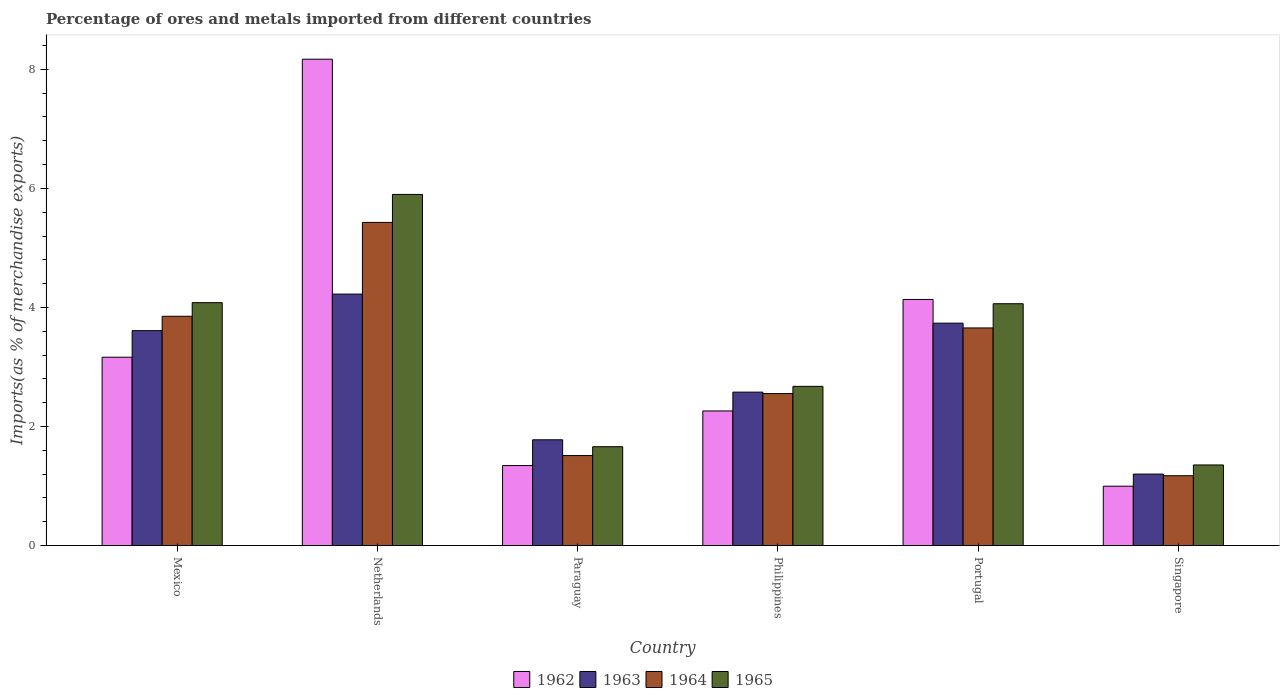How many different coloured bars are there?
Give a very brief answer. 4. How many bars are there on the 6th tick from the left?
Provide a short and direct response. 4. What is the label of the 6th group of bars from the left?
Provide a short and direct response. Singapore. In how many cases, is the number of bars for a given country not equal to the number of legend labels?
Make the answer very short. 0. What is the percentage of imports to different countries in 1964 in Paraguay?
Offer a very short reply. 1.51. Across all countries, what is the maximum percentage of imports to different countries in 1964?
Give a very brief answer. 5.43. Across all countries, what is the minimum percentage of imports to different countries in 1962?
Provide a short and direct response. 1. In which country was the percentage of imports to different countries in 1962 maximum?
Your response must be concise. Netherlands. In which country was the percentage of imports to different countries in 1962 minimum?
Offer a terse response. Singapore. What is the total percentage of imports to different countries in 1964 in the graph?
Give a very brief answer. 18.18. What is the difference between the percentage of imports to different countries in 1963 in Netherlands and that in Singapore?
Your answer should be compact. 3.02. What is the difference between the percentage of imports to different countries in 1962 in Singapore and the percentage of imports to different countries in 1964 in Philippines?
Your response must be concise. -1.56. What is the average percentage of imports to different countries in 1965 per country?
Make the answer very short. 3.29. What is the difference between the percentage of imports to different countries of/in 1963 and percentage of imports to different countries of/in 1962 in Paraguay?
Your answer should be compact. 0.43. In how many countries, is the percentage of imports to different countries in 1965 greater than 0.8 %?
Offer a terse response. 6. What is the ratio of the percentage of imports to different countries in 1963 in Philippines to that in Singapore?
Ensure brevity in your answer.  2.15. Is the percentage of imports to different countries in 1965 in Philippines less than that in Portugal?
Offer a very short reply. Yes. Is the difference between the percentage of imports to different countries in 1963 in Netherlands and Singapore greater than the difference between the percentage of imports to different countries in 1962 in Netherlands and Singapore?
Your answer should be very brief. No. What is the difference between the highest and the second highest percentage of imports to different countries in 1965?
Offer a terse response. -0.02. What is the difference between the highest and the lowest percentage of imports to different countries in 1963?
Make the answer very short. 3.02. In how many countries, is the percentage of imports to different countries in 1964 greater than the average percentage of imports to different countries in 1964 taken over all countries?
Provide a short and direct response. 3. Is it the case that in every country, the sum of the percentage of imports to different countries in 1963 and percentage of imports to different countries in 1965 is greater than the sum of percentage of imports to different countries in 1962 and percentage of imports to different countries in 1964?
Your answer should be very brief. No. What does the 3rd bar from the left in Portugal represents?
Your answer should be compact. 1964. Are all the bars in the graph horizontal?
Ensure brevity in your answer.  No. How many countries are there in the graph?
Offer a terse response. 6. What is the difference between two consecutive major ticks on the Y-axis?
Make the answer very short. 2. Are the values on the major ticks of Y-axis written in scientific E-notation?
Your answer should be very brief. No. Does the graph contain any zero values?
Offer a terse response. No. How many legend labels are there?
Keep it short and to the point. 4. What is the title of the graph?
Provide a short and direct response. Percentage of ores and metals imported from different countries. Does "1961" appear as one of the legend labels in the graph?
Keep it short and to the point. No. What is the label or title of the Y-axis?
Your answer should be compact. Imports(as % of merchandise exports). What is the Imports(as % of merchandise exports) in 1962 in Mexico?
Make the answer very short. 3.16. What is the Imports(as % of merchandise exports) in 1963 in Mexico?
Your answer should be compact. 3.61. What is the Imports(as % of merchandise exports) of 1964 in Mexico?
Your response must be concise. 3.85. What is the Imports(as % of merchandise exports) of 1965 in Mexico?
Offer a terse response. 4.08. What is the Imports(as % of merchandise exports) of 1962 in Netherlands?
Your answer should be very brief. 8.17. What is the Imports(as % of merchandise exports) in 1963 in Netherlands?
Provide a short and direct response. 4.22. What is the Imports(as % of merchandise exports) of 1964 in Netherlands?
Offer a very short reply. 5.43. What is the Imports(as % of merchandise exports) of 1965 in Netherlands?
Offer a terse response. 5.9. What is the Imports(as % of merchandise exports) in 1962 in Paraguay?
Your answer should be very brief. 1.34. What is the Imports(as % of merchandise exports) in 1963 in Paraguay?
Make the answer very short. 1.78. What is the Imports(as % of merchandise exports) in 1964 in Paraguay?
Your response must be concise. 1.51. What is the Imports(as % of merchandise exports) in 1965 in Paraguay?
Keep it short and to the point. 1.66. What is the Imports(as % of merchandise exports) of 1962 in Philippines?
Provide a short and direct response. 2.26. What is the Imports(as % of merchandise exports) in 1963 in Philippines?
Offer a very short reply. 2.58. What is the Imports(as % of merchandise exports) in 1964 in Philippines?
Provide a short and direct response. 2.55. What is the Imports(as % of merchandise exports) of 1965 in Philippines?
Keep it short and to the point. 2.67. What is the Imports(as % of merchandise exports) of 1962 in Portugal?
Give a very brief answer. 4.13. What is the Imports(as % of merchandise exports) in 1963 in Portugal?
Your response must be concise. 3.74. What is the Imports(as % of merchandise exports) in 1964 in Portugal?
Offer a very short reply. 3.66. What is the Imports(as % of merchandise exports) in 1965 in Portugal?
Your answer should be compact. 4.06. What is the Imports(as % of merchandise exports) in 1962 in Singapore?
Offer a terse response. 1. What is the Imports(as % of merchandise exports) in 1963 in Singapore?
Offer a terse response. 1.2. What is the Imports(as % of merchandise exports) in 1964 in Singapore?
Provide a short and direct response. 1.17. What is the Imports(as % of merchandise exports) of 1965 in Singapore?
Provide a succinct answer. 1.35. Across all countries, what is the maximum Imports(as % of merchandise exports) in 1962?
Provide a succinct answer. 8.17. Across all countries, what is the maximum Imports(as % of merchandise exports) of 1963?
Keep it short and to the point. 4.22. Across all countries, what is the maximum Imports(as % of merchandise exports) in 1964?
Give a very brief answer. 5.43. Across all countries, what is the maximum Imports(as % of merchandise exports) in 1965?
Your response must be concise. 5.9. Across all countries, what is the minimum Imports(as % of merchandise exports) of 1962?
Provide a succinct answer. 1. Across all countries, what is the minimum Imports(as % of merchandise exports) of 1963?
Give a very brief answer. 1.2. Across all countries, what is the minimum Imports(as % of merchandise exports) in 1964?
Keep it short and to the point. 1.17. Across all countries, what is the minimum Imports(as % of merchandise exports) of 1965?
Provide a succinct answer. 1.35. What is the total Imports(as % of merchandise exports) of 1962 in the graph?
Offer a very short reply. 20.07. What is the total Imports(as % of merchandise exports) in 1963 in the graph?
Ensure brevity in your answer.  17.13. What is the total Imports(as % of merchandise exports) of 1964 in the graph?
Provide a short and direct response. 18.18. What is the total Imports(as % of merchandise exports) of 1965 in the graph?
Offer a terse response. 19.73. What is the difference between the Imports(as % of merchandise exports) of 1962 in Mexico and that in Netherlands?
Give a very brief answer. -5.01. What is the difference between the Imports(as % of merchandise exports) in 1963 in Mexico and that in Netherlands?
Your answer should be very brief. -0.61. What is the difference between the Imports(as % of merchandise exports) in 1964 in Mexico and that in Netherlands?
Your response must be concise. -1.58. What is the difference between the Imports(as % of merchandise exports) in 1965 in Mexico and that in Netherlands?
Offer a terse response. -1.82. What is the difference between the Imports(as % of merchandise exports) of 1962 in Mexico and that in Paraguay?
Keep it short and to the point. 1.82. What is the difference between the Imports(as % of merchandise exports) of 1963 in Mexico and that in Paraguay?
Your answer should be very brief. 1.83. What is the difference between the Imports(as % of merchandise exports) in 1964 in Mexico and that in Paraguay?
Offer a very short reply. 2.34. What is the difference between the Imports(as % of merchandise exports) of 1965 in Mexico and that in Paraguay?
Your response must be concise. 2.42. What is the difference between the Imports(as % of merchandise exports) of 1962 in Mexico and that in Philippines?
Make the answer very short. 0.9. What is the difference between the Imports(as % of merchandise exports) of 1963 in Mexico and that in Philippines?
Provide a succinct answer. 1.03. What is the difference between the Imports(as % of merchandise exports) of 1964 in Mexico and that in Philippines?
Your answer should be very brief. 1.3. What is the difference between the Imports(as % of merchandise exports) in 1965 in Mexico and that in Philippines?
Offer a terse response. 1.41. What is the difference between the Imports(as % of merchandise exports) in 1962 in Mexico and that in Portugal?
Offer a very short reply. -0.97. What is the difference between the Imports(as % of merchandise exports) of 1963 in Mexico and that in Portugal?
Your response must be concise. -0.13. What is the difference between the Imports(as % of merchandise exports) of 1964 in Mexico and that in Portugal?
Offer a terse response. 0.2. What is the difference between the Imports(as % of merchandise exports) in 1965 in Mexico and that in Portugal?
Offer a very short reply. 0.02. What is the difference between the Imports(as % of merchandise exports) in 1962 in Mexico and that in Singapore?
Your answer should be very brief. 2.17. What is the difference between the Imports(as % of merchandise exports) of 1963 in Mexico and that in Singapore?
Your response must be concise. 2.41. What is the difference between the Imports(as % of merchandise exports) of 1964 in Mexico and that in Singapore?
Offer a terse response. 2.68. What is the difference between the Imports(as % of merchandise exports) in 1965 in Mexico and that in Singapore?
Offer a very short reply. 2.73. What is the difference between the Imports(as % of merchandise exports) in 1962 in Netherlands and that in Paraguay?
Your answer should be compact. 6.83. What is the difference between the Imports(as % of merchandise exports) of 1963 in Netherlands and that in Paraguay?
Provide a succinct answer. 2.45. What is the difference between the Imports(as % of merchandise exports) in 1964 in Netherlands and that in Paraguay?
Provide a succinct answer. 3.92. What is the difference between the Imports(as % of merchandise exports) of 1965 in Netherlands and that in Paraguay?
Provide a short and direct response. 4.24. What is the difference between the Imports(as % of merchandise exports) of 1962 in Netherlands and that in Philippines?
Your answer should be very brief. 5.91. What is the difference between the Imports(as % of merchandise exports) of 1963 in Netherlands and that in Philippines?
Offer a terse response. 1.65. What is the difference between the Imports(as % of merchandise exports) in 1964 in Netherlands and that in Philippines?
Give a very brief answer. 2.88. What is the difference between the Imports(as % of merchandise exports) in 1965 in Netherlands and that in Philippines?
Provide a short and direct response. 3.22. What is the difference between the Imports(as % of merchandise exports) of 1962 in Netherlands and that in Portugal?
Make the answer very short. 4.04. What is the difference between the Imports(as % of merchandise exports) of 1963 in Netherlands and that in Portugal?
Offer a terse response. 0.49. What is the difference between the Imports(as % of merchandise exports) of 1964 in Netherlands and that in Portugal?
Keep it short and to the point. 1.77. What is the difference between the Imports(as % of merchandise exports) in 1965 in Netherlands and that in Portugal?
Your answer should be very brief. 1.84. What is the difference between the Imports(as % of merchandise exports) of 1962 in Netherlands and that in Singapore?
Keep it short and to the point. 7.17. What is the difference between the Imports(as % of merchandise exports) of 1963 in Netherlands and that in Singapore?
Your answer should be very brief. 3.02. What is the difference between the Imports(as % of merchandise exports) in 1964 in Netherlands and that in Singapore?
Offer a terse response. 4.26. What is the difference between the Imports(as % of merchandise exports) of 1965 in Netherlands and that in Singapore?
Your response must be concise. 4.55. What is the difference between the Imports(as % of merchandise exports) of 1962 in Paraguay and that in Philippines?
Offer a terse response. -0.92. What is the difference between the Imports(as % of merchandise exports) of 1963 in Paraguay and that in Philippines?
Offer a terse response. -0.8. What is the difference between the Imports(as % of merchandise exports) in 1964 in Paraguay and that in Philippines?
Offer a terse response. -1.04. What is the difference between the Imports(as % of merchandise exports) in 1965 in Paraguay and that in Philippines?
Ensure brevity in your answer.  -1.01. What is the difference between the Imports(as % of merchandise exports) of 1962 in Paraguay and that in Portugal?
Give a very brief answer. -2.79. What is the difference between the Imports(as % of merchandise exports) of 1963 in Paraguay and that in Portugal?
Provide a short and direct response. -1.96. What is the difference between the Imports(as % of merchandise exports) of 1964 in Paraguay and that in Portugal?
Make the answer very short. -2.14. What is the difference between the Imports(as % of merchandise exports) of 1965 in Paraguay and that in Portugal?
Ensure brevity in your answer.  -2.4. What is the difference between the Imports(as % of merchandise exports) in 1962 in Paraguay and that in Singapore?
Provide a succinct answer. 0.35. What is the difference between the Imports(as % of merchandise exports) of 1963 in Paraguay and that in Singapore?
Your answer should be compact. 0.58. What is the difference between the Imports(as % of merchandise exports) in 1964 in Paraguay and that in Singapore?
Ensure brevity in your answer.  0.34. What is the difference between the Imports(as % of merchandise exports) of 1965 in Paraguay and that in Singapore?
Your response must be concise. 0.31. What is the difference between the Imports(as % of merchandise exports) in 1962 in Philippines and that in Portugal?
Your answer should be very brief. -1.87. What is the difference between the Imports(as % of merchandise exports) of 1963 in Philippines and that in Portugal?
Give a very brief answer. -1.16. What is the difference between the Imports(as % of merchandise exports) of 1964 in Philippines and that in Portugal?
Your answer should be very brief. -1.1. What is the difference between the Imports(as % of merchandise exports) of 1965 in Philippines and that in Portugal?
Keep it short and to the point. -1.39. What is the difference between the Imports(as % of merchandise exports) in 1962 in Philippines and that in Singapore?
Make the answer very short. 1.26. What is the difference between the Imports(as % of merchandise exports) of 1963 in Philippines and that in Singapore?
Your answer should be compact. 1.38. What is the difference between the Imports(as % of merchandise exports) of 1964 in Philippines and that in Singapore?
Provide a short and direct response. 1.38. What is the difference between the Imports(as % of merchandise exports) in 1965 in Philippines and that in Singapore?
Provide a short and direct response. 1.32. What is the difference between the Imports(as % of merchandise exports) of 1962 in Portugal and that in Singapore?
Your answer should be compact. 3.14. What is the difference between the Imports(as % of merchandise exports) in 1963 in Portugal and that in Singapore?
Keep it short and to the point. 2.54. What is the difference between the Imports(as % of merchandise exports) in 1964 in Portugal and that in Singapore?
Make the answer very short. 2.48. What is the difference between the Imports(as % of merchandise exports) in 1965 in Portugal and that in Singapore?
Your answer should be compact. 2.71. What is the difference between the Imports(as % of merchandise exports) of 1962 in Mexico and the Imports(as % of merchandise exports) of 1963 in Netherlands?
Your response must be concise. -1.06. What is the difference between the Imports(as % of merchandise exports) of 1962 in Mexico and the Imports(as % of merchandise exports) of 1964 in Netherlands?
Your answer should be very brief. -2.26. What is the difference between the Imports(as % of merchandise exports) in 1962 in Mexico and the Imports(as % of merchandise exports) in 1965 in Netherlands?
Your answer should be very brief. -2.73. What is the difference between the Imports(as % of merchandise exports) of 1963 in Mexico and the Imports(as % of merchandise exports) of 1964 in Netherlands?
Offer a very short reply. -1.82. What is the difference between the Imports(as % of merchandise exports) of 1963 in Mexico and the Imports(as % of merchandise exports) of 1965 in Netherlands?
Ensure brevity in your answer.  -2.29. What is the difference between the Imports(as % of merchandise exports) in 1964 in Mexico and the Imports(as % of merchandise exports) in 1965 in Netherlands?
Provide a succinct answer. -2.05. What is the difference between the Imports(as % of merchandise exports) of 1962 in Mexico and the Imports(as % of merchandise exports) of 1963 in Paraguay?
Keep it short and to the point. 1.39. What is the difference between the Imports(as % of merchandise exports) in 1962 in Mexico and the Imports(as % of merchandise exports) in 1964 in Paraguay?
Make the answer very short. 1.65. What is the difference between the Imports(as % of merchandise exports) of 1962 in Mexico and the Imports(as % of merchandise exports) of 1965 in Paraguay?
Offer a terse response. 1.5. What is the difference between the Imports(as % of merchandise exports) of 1963 in Mexico and the Imports(as % of merchandise exports) of 1964 in Paraguay?
Provide a short and direct response. 2.1. What is the difference between the Imports(as % of merchandise exports) of 1963 in Mexico and the Imports(as % of merchandise exports) of 1965 in Paraguay?
Offer a very short reply. 1.95. What is the difference between the Imports(as % of merchandise exports) of 1964 in Mexico and the Imports(as % of merchandise exports) of 1965 in Paraguay?
Provide a succinct answer. 2.19. What is the difference between the Imports(as % of merchandise exports) of 1962 in Mexico and the Imports(as % of merchandise exports) of 1963 in Philippines?
Ensure brevity in your answer.  0.59. What is the difference between the Imports(as % of merchandise exports) of 1962 in Mexico and the Imports(as % of merchandise exports) of 1964 in Philippines?
Offer a very short reply. 0.61. What is the difference between the Imports(as % of merchandise exports) of 1962 in Mexico and the Imports(as % of merchandise exports) of 1965 in Philippines?
Your response must be concise. 0.49. What is the difference between the Imports(as % of merchandise exports) of 1963 in Mexico and the Imports(as % of merchandise exports) of 1964 in Philippines?
Your answer should be very brief. 1.06. What is the difference between the Imports(as % of merchandise exports) in 1963 in Mexico and the Imports(as % of merchandise exports) in 1965 in Philippines?
Keep it short and to the point. 0.94. What is the difference between the Imports(as % of merchandise exports) in 1964 in Mexico and the Imports(as % of merchandise exports) in 1965 in Philippines?
Make the answer very short. 1.18. What is the difference between the Imports(as % of merchandise exports) in 1962 in Mexico and the Imports(as % of merchandise exports) in 1963 in Portugal?
Provide a succinct answer. -0.57. What is the difference between the Imports(as % of merchandise exports) in 1962 in Mexico and the Imports(as % of merchandise exports) in 1964 in Portugal?
Provide a succinct answer. -0.49. What is the difference between the Imports(as % of merchandise exports) of 1962 in Mexico and the Imports(as % of merchandise exports) of 1965 in Portugal?
Make the answer very short. -0.9. What is the difference between the Imports(as % of merchandise exports) in 1963 in Mexico and the Imports(as % of merchandise exports) in 1964 in Portugal?
Make the answer very short. -0.05. What is the difference between the Imports(as % of merchandise exports) of 1963 in Mexico and the Imports(as % of merchandise exports) of 1965 in Portugal?
Your response must be concise. -0.45. What is the difference between the Imports(as % of merchandise exports) of 1964 in Mexico and the Imports(as % of merchandise exports) of 1965 in Portugal?
Provide a short and direct response. -0.21. What is the difference between the Imports(as % of merchandise exports) of 1962 in Mexico and the Imports(as % of merchandise exports) of 1963 in Singapore?
Give a very brief answer. 1.96. What is the difference between the Imports(as % of merchandise exports) in 1962 in Mexico and the Imports(as % of merchandise exports) in 1964 in Singapore?
Ensure brevity in your answer.  1.99. What is the difference between the Imports(as % of merchandise exports) of 1962 in Mexico and the Imports(as % of merchandise exports) of 1965 in Singapore?
Make the answer very short. 1.81. What is the difference between the Imports(as % of merchandise exports) in 1963 in Mexico and the Imports(as % of merchandise exports) in 1964 in Singapore?
Offer a terse response. 2.44. What is the difference between the Imports(as % of merchandise exports) of 1963 in Mexico and the Imports(as % of merchandise exports) of 1965 in Singapore?
Your response must be concise. 2.26. What is the difference between the Imports(as % of merchandise exports) in 1964 in Mexico and the Imports(as % of merchandise exports) in 1965 in Singapore?
Your response must be concise. 2.5. What is the difference between the Imports(as % of merchandise exports) in 1962 in Netherlands and the Imports(as % of merchandise exports) in 1963 in Paraguay?
Ensure brevity in your answer.  6.39. What is the difference between the Imports(as % of merchandise exports) in 1962 in Netherlands and the Imports(as % of merchandise exports) in 1964 in Paraguay?
Your response must be concise. 6.66. What is the difference between the Imports(as % of merchandise exports) of 1962 in Netherlands and the Imports(as % of merchandise exports) of 1965 in Paraguay?
Offer a terse response. 6.51. What is the difference between the Imports(as % of merchandise exports) of 1963 in Netherlands and the Imports(as % of merchandise exports) of 1964 in Paraguay?
Offer a terse response. 2.71. What is the difference between the Imports(as % of merchandise exports) in 1963 in Netherlands and the Imports(as % of merchandise exports) in 1965 in Paraguay?
Offer a very short reply. 2.56. What is the difference between the Imports(as % of merchandise exports) in 1964 in Netherlands and the Imports(as % of merchandise exports) in 1965 in Paraguay?
Provide a succinct answer. 3.77. What is the difference between the Imports(as % of merchandise exports) in 1962 in Netherlands and the Imports(as % of merchandise exports) in 1963 in Philippines?
Your response must be concise. 5.59. What is the difference between the Imports(as % of merchandise exports) of 1962 in Netherlands and the Imports(as % of merchandise exports) of 1964 in Philippines?
Your answer should be very brief. 5.62. What is the difference between the Imports(as % of merchandise exports) in 1962 in Netherlands and the Imports(as % of merchandise exports) in 1965 in Philippines?
Your answer should be compact. 5.5. What is the difference between the Imports(as % of merchandise exports) of 1963 in Netherlands and the Imports(as % of merchandise exports) of 1964 in Philippines?
Your answer should be compact. 1.67. What is the difference between the Imports(as % of merchandise exports) in 1963 in Netherlands and the Imports(as % of merchandise exports) in 1965 in Philippines?
Make the answer very short. 1.55. What is the difference between the Imports(as % of merchandise exports) of 1964 in Netherlands and the Imports(as % of merchandise exports) of 1965 in Philippines?
Make the answer very short. 2.75. What is the difference between the Imports(as % of merchandise exports) in 1962 in Netherlands and the Imports(as % of merchandise exports) in 1963 in Portugal?
Keep it short and to the point. 4.43. What is the difference between the Imports(as % of merchandise exports) of 1962 in Netherlands and the Imports(as % of merchandise exports) of 1964 in Portugal?
Offer a terse response. 4.51. What is the difference between the Imports(as % of merchandise exports) in 1962 in Netherlands and the Imports(as % of merchandise exports) in 1965 in Portugal?
Your answer should be compact. 4.11. What is the difference between the Imports(as % of merchandise exports) in 1963 in Netherlands and the Imports(as % of merchandise exports) in 1964 in Portugal?
Keep it short and to the point. 0.57. What is the difference between the Imports(as % of merchandise exports) of 1963 in Netherlands and the Imports(as % of merchandise exports) of 1965 in Portugal?
Your answer should be very brief. 0.16. What is the difference between the Imports(as % of merchandise exports) in 1964 in Netherlands and the Imports(as % of merchandise exports) in 1965 in Portugal?
Keep it short and to the point. 1.37. What is the difference between the Imports(as % of merchandise exports) of 1962 in Netherlands and the Imports(as % of merchandise exports) of 1963 in Singapore?
Ensure brevity in your answer.  6.97. What is the difference between the Imports(as % of merchandise exports) in 1962 in Netherlands and the Imports(as % of merchandise exports) in 1964 in Singapore?
Offer a terse response. 7. What is the difference between the Imports(as % of merchandise exports) of 1962 in Netherlands and the Imports(as % of merchandise exports) of 1965 in Singapore?
Provide a short and direct response. 6.82. What is the difference between the Imports(as % of merchandise exports) of 1963 in Netherlands and the Imports(as % of merchandise exports) of 1964 in Singapore?
Your answer should be very brief. 3.05. What is the difference between the Imports(as % of merchandise exports) in 1963 in Netherlands and the Imports(as % of merchandise exports) in 1965 in Singapore?
Offer a terse response. 2.87. What is the difference between the Imports(as % of merchandise exports) of 1964 in Netherlands and the Imports(as % of merchandise exports) of 1965 in Singapore?
Make the answer very short. 4.07. What is the difference between the Imports(as % of merchandise exports) of 1962 in Paraguay and the Imports(as % of merchandise exports) of 1963 in Philippines?
Your answer should be very brief. -1.23. What is the difference between the Imports(as % of merchandise exports) in 1962 in Paraguay and the Imports(as % of merchandise exports) in 1964 in Philippines?
Your answer should be compact. -1.21. What is the difference between the Imports(as % of merchandise exports) in 1962 in Paraguay and the Imports(as % of merchandise exports) in 1965 in Philippines?
Your response must be concise. -1.33. What is the difference between the Imports(as % of merchandise exports) in 1963 in Paraguay and the Imports(as % of merchandise exports) in 1964 in Philippines?
Make the answer very short. -0.78. What is the difference between the Imports(as % of merchandise exports) of 1963 in Paraguay and the Imports(as % of merchandise exports) of 1965 in Philippines?
Provide a succinct answer. -0.9. What is the difference between the Imports(as % of merchandise exports) in 1964 in Paraguay and the Imports(as % of merchandise exports) in 1965 in Philippines?
Give a very brief answer. -1.16. What is the difference between the Imports(as % of merchandise exports) in 1962 in Paraguay and the Imports(as % of merchandise exports) in 1963 in Portugal?
Provide a succinct answer. -2.39. What is the difference between the Imports(as % of merchandise exports) of 1962 in Paraguay and the Imports(as % of merchandise exports) of 1964 in Portugal?
Keep it short and to the point. -2.31. What is the difference between the Imports(as % of merchandise exports) in 1962 in Paraguay and the Imports(as % of merchandise exports) in 1965 in Portugal?
Offer a terse response. -2.72. What is the difference between the Imports(as % of merchandise exports) in 1963 in Paraguay and the Imports(as % of merchandise exports) in 1964 in Portugal?
Give a very brief answer. -1.88. What is the difference between the Imports(as % of merchandise exports) in 1963 in Paraguay and the Imports(as % of merchandise exports) in 1965 in Portugal?
Your response must be concise. -2.29. What is the difference between the Imports(as % of merchandise exports) in 1964 in Paraguay and the Imports(as % of merchandise exports) in 1965 in Portugal?
Your answer should be very brief. -2.55. What is the difference between the Imports(as % of merchandise exports) in 1962 in Paraguay and the Imports(as % of merchandise exports) in 1963 in Singapore?
Offer a terse response. 0.14. What is the difference between the Imports(as % of merchandise exports) of 1962 in Paraguay and the Imports(as % of merchandise exports) of 1964 in Singapore?
Give a very brief answer. 0.17. What is the difference between the Imports(as % of merchandise exports) of 1962 in Paraguay and the Imports(as % of merchandise exports) of 1965 in Singapore?
Offer a very short reply. -0.01. What is the difference between the Imports(as % of merchandise exports) of 1963 in Paraguay and the Imports(as % of merchandise exports) of 1964 in Singapore?
Ensure brevity in your answer.  0.6. What is the difference between the Imports(as % of merchandise exports) in 1963 in Paraguay and the Imports(as % of merchandise exports) in 1965 in Singapore?
Offer a terse response. 0.42. What is the difference between the Imports(as % of merchandise exports) in 1964 in Paraguay and the Imports(as % of merchandise exports) in 1965 in Singapore?
Ensure brevity in your answer.  0.16. What is the difference between the Imports(as % of merchandise exports) of 1962 in Philippines and the Imports(as % of merchandise exports) of 1963 in Portugal?
Provide a succinct answer. -1.47. What is the difference between the Imports(as % of merchandise exports) of 1962 in Philippines and the Imports(as % of merchandise exports) of 1964 in Portugal?
Offer a terse response. -1.39. What is the difference between the Imports(as % of merchandise exports) in 1962 in Philippines and the Imports(as % of merchandise exports) in 1965 in Portugal?
Your answer should be very brief. -1.8. What is the difference between the Imports(as % of merchandise exports) in 1963 in Philippines and the Imports(as % of merchandise exports) in 1964 in Portugal?
Offer a terse response. -1.08. What is the difference between the Imports(as % of merchandise exports) of 1963 in Philippines and the Imports(as % of merchandise exports) of 1965 in Portugal?
Your response must be concise. -1.48. What is the difference between the Imports(as % of merchandise exports) in 1964 in Philippines and the Imports(as % of merchandise exports) in 1965 in Portugal?
Your answer should be compact. -1.51. What is the difference between the Imports(as % of merchandise exports) of 1962 in Philippines and the Imports(as % of merchandise exports) of 1963 in Singapore?
Give a very brief answer. 1.06. What is the difference between the Imports(as % of merchandise exports) in 1962 in Philippines and the Imports(as % of merchandise exports) in 1964 in Singapore?
Keep it short and to the point. 1.09. What is the difference between the Imports(as % of merchandise exports) of 1962 in Philippines and the Imports(as % of merchandise exports) of 1965 in Singapore?
Your response must be concise. 0.91. What is the difference between the Imports(as % of merchandise exports) of 1963 in Philippines and the Imports(as % of merchandise exports) of 1964 in Singapore?
Ensure brevity in your answer.  1.4. What is the difference between the Imports(as % of merchandise exports) in 1963 in Philippines and the Imports(as % of merchandise exports) in 1965 in Singapore?
Offer a very short reply. 1.22. What is the difference between the Imports(as % of merchandise exports) of 1964 in Philippines and the Imports(as % of merchandise exports) of 1965 in Singapore?
Keep it short and to the point. 1.2. What is the difference between the Imports(as % of merchandise exports) of 1962 in Portugal and the Imports(as % of merchandise exports) of 1963 in Singapore?
Make the answer very short. 2.93. What is the difference between the Imports(as % of merchandise exports) of 1962 in Portugal and the Imports(as % of merchandise exports) of 1964 in Singapore?
Make the answer very short. 2.96. What is the difference between the Imports(as % of merchandise exports) of 1962 in Portugal and the Imports(as % of merchandise exports) of 1965 in Singapore?
Make the answer very short. 2.78. What is the difference between the Imports(as % of merchandise exports) in 1963 in Portugal and the Imports(as % of merchandise exports) in 1964 in Singapore?
Keep it short and to the point. 2.56. What is the difference between the Imports(as % of merchandise exports) in 1963 in Portugal and the Imports(as % of merchandise exports) in 1965 in Singapore?
Provide a succinct answer. 2.38. What is the difference between the Imports(as % of merchandise exports) in 1964 in Portugal and the Imports(as % of merchandise exports) in 1965 in Singapore?
Keep it short and to the point. 2.3. What is the average Imports(as % of merchandise exports) in 1962 per country?
Your answer should be compact. 3.35. What is the average Imports(as % of merchandise exports) of 1963 per country?
Offer a very short reply. 2.85. What is the average Imports(as % of merchandise exports) of 1964 per country?
Your response must be concise. 3.03. What is the average Imports(as % of merchandise exports) in 1965 per country?
Provide a short and direct response. 3.29. What is the difference between the Imports(as % of merchandise exports) of 1962 and Imports(as % of merchandise exports) of 1963 in Mexico?
Ensure brevity in your answer.  -0.45. What is the difference between the Imports(as % of merchandise exports) in 1962 and Imports(as % of merchandise exports) in 1964 in Mexico?
Offer a very short reply. -0.69. What is the difference between the Imports(as % of merchandise exports) of 1962 and Imports(as % of merchandise exports) of 1965 in Mexico?
Make the answer very short. -0.92. What is the difference between the Imports(as % of merchandise exports) in 1963 and Imports(as % of merchandise exports) in 1964 in Mexico?
Offer a terse response. -0.24. What is the difference between the Imports(as % of merchandise exports) in 1963 and Imports(as % of merchandise exports) in 1965 in Mexico?
Provide a short and direct response. -0.47. What is the difference between the Imports(as % of merchandise exports) in 1964 and Imports(as % of merchandise exports) in 1965 in Mexico?
Provide a succinct answer. -0.23. What is the difference between the Imports(as % of merchandise exports) of 1962 and Imports(as % of merchandise exports) of 1963 in Netherlands?
Ensure brevity in your answer.  3.95. What is the difference between the Imports(as % of merchandise exports) of 1962 and Imports(as % of merchandise exports) of 1964 in Netherlands?
Ensure brevity in your answer.  2.74. What is the difference between the Imports(as % of merchandise exports) in 1962 and Imports(as % of merchandise exports) in 1965 in Netherlands?
Offer a terse response. 2.27. What is the difference between the Imports(as % of merchandise exports) in 1963 and Imports(as % of merchandise exports) in 1964 in Netherlands?
Your answer should be very brief. -1.2. What is the difference between the Imports(as % of merchandise exports) of 1963 and Imports(as % of merchandise exports) of 1965 in Netherlands?
Make the answer very short. -1.67. What is the difference between the Imports(as % of merchandise exports) in 1964 and Imports(as % of merchandise exports) in 1965 in Netherlands?
Offer a terse response. -0.47. What is the difference between the Imports(as % of merchandise exports) in 1962 and Imports(as % of merchandise exports) in 1963 in Paraguay?
Keep it short and to the point. -0.43. What is the difference between the Imports(as % of merchandise exports) in 1962 and Imports(as % of merchandise exports) in 1964 in Paraguay?
Ensure brevity in your answer.  -0.17. What is the difference between the Imports(as % of merchandise exports) in 1962 and Imports(as % of merchandise exports) in 1965 in Paraguay?
Your response must be concise. -0.32. What is the difference between the Imports(as % of merchandise exports) in 1963 and Imports(as % of merchandise exports) in 1964 in Paraguay?
Ensure brevity in your answer.  0.26. What is the difference between the Imports(as % of merchandise exports) in 1963 and Imports(as % of merchandise exports) in 1965 in Paraguay?
Offer a very short reply. 0.12. What is the difference between the Imports(as % of merchandise exports) of 1964 and Imports(as % of merchandise exports) of 1965 in Paraguay?
Keep it short and to the point. -0.15. What is the difference between the Imports(as % of merchandise exports) of 1962 and Imports(as % of merchandise exports) of 1963 in Philippines?
Offer a very short reply. -0.32. What is the difference between the Imports(as % of merchandise exports) in 1962 and Imports(as % of merchandise exports) in 1964 in Philippines?
Provide a short and direct response. -0.29. What is the difference between the Imports(as % of merchandise exports) of 1962 and Imports(as % of merchandise exports) of 1965 in Philippines?
Provide a succinct answer. -0.41. What is the difference between the Imports(as % of merchandise exports) of 1963 and Imports(as % of merchandise exports) of 1964 in Philippines?
Provide a short and direct response. 0.02. What is the difference between the Imports(as % of merchandise exports) in 1963 and Imports(as % of merchandise exports) in 1965 in Philippines?
Provide a short and direct response. -0.1. What is the difference between the Imports(as % of merchandise exports) in 1964 and Imports(as % of merchandise exports) in 1965 in Philippines?
Ensure brevity in your answer.  -0.12. What is the difference between the Imports(as % of merchandise exports) in 1962 and Imports(as % of merchandise exports) in 1963 in Portugal?
Offer a very short reply. 0.4. What is the difference between the Imports(as % of merchandise exports) of 1962 and Imports(as % of merchandise exports) of 1964 in Portugal?
Keep it short and to the point. 0.48. What is the difference between the Imports(as % of merchandise exports) of 1962 and Imports(as % of merchandise exports) of 1965 in Portugal?
Provide a succinct answer. 0.07. What is the difference between the Imports(as % of merchandise exports) of 1963 and Imports(as % of merchandise exports) of 1964 in Portugal?
Offer a terse response. 0.08. What is the difference between the Imports(as % of merchandise exports) in 1963 and Imports(as % of merchandise exports) in 1965 in Portugal?
Make the answer very short. -0.33. What is the difference between the Imports(as % of merchandise exports) of 1964 and Imports(as % of merchandise exports) of 1965 in Portugal?
Make the answer very short. -0.41. What is the difference between the Imports(as % of merchandise exports) of 1962 and Imports(as % of merchandise exports) of 1963 in Singapore?
Give a very brief answer. -0.2. What is the difference between the Imports(as % of merchandise exports) of 1962 and Imports(as % of merchandise exports) of 1964 in Singapore?
Offer a terse response. -0.18. What is the difference between the Imports(as % of merchandise exports) of 1962 and Imports(as % of merchandise exports) of 1965 in Singapore?
Offer a terse response. -0.36. What is the difference between the Imports(as % of merchandise exports) in 1963 and Imports(as % of merchandise exports) in 1964 in Singapore?
Offer a terse response. 0.03. What is the difference between the Imports(as % of merchandise exports) of 1963 and Imports(as % of merchandise exports) of 1965 in Singapore?
Provide a succinct answer. -0.15. What is the difference between the Imports(as % of merchandise exports) in 1964 and Imports(as % of merchandise exports) in 1965 in Singapore?
Offer a terse response. -0.18. What is the ratio of the Imports(as % of merchandise exports) of 1962 in Mexico to that in Netherlands?
Your answer should be compact. 0.39. What is the ratio of the Imports(as % of merchandise exports) in 1963 in Mexico to that in Netherlands?
Your answer should be compact. 0.85. What is the ratio of the Imports(as % of merchandise exports) of 1964 in Mexico to that in Netherlands?
Keep it short and to the point. 0.71. What is the ratio of the Imports(as % of merchandise exports) in 1965 in Mexico to that in Netherlands?
Offer a very short reply. 0.69. What is the ratio of the Imports(as % of merchandise exports) of 1962 in Mexico to that in Paraguay?
Offer a terse response. 2.35. What is the ratio of the Imports(as % of merchandise exports) in 1963 in Mexico to that in Paraguay?
Ensure brevity in your answer.  2.03. What is the ratio of the Imports(as % of merchandise exports) in 1964 in Mexico to that in Paraguay?
Provide a short and direct response. 2.55. What is the ratio of the Imports(as % of merchandise exports) in 1965 in Mexico to that in Paraguay?
Offer a terse response. 2.46. What is the ratio of the Imports(as % of merchandise exports) of 1962 in Mexico to that in Philippines?
Offer a very short reply. 1.4. What is the ratio of the Imports(as % of merchandise exports) in 1963 in Mexico to that in Philippines?
Provide a short and direct response. 1.4. What is the ratio of the Imports(as % of merchandise exports) in 1964 in Mexico to that in Philippines?
Offer a terse response. 1.51. What is the ratio of the Imports(as % of merchandise exports) of 1965 in Mexico to that in Philippines?
Ensure brevity in your answer.  1.53. What is the ratio of the Imports(as % of merchandise exports) in 1962 in Mexico to that in Portugal?
Your answer should be very brief. 0.77. What is the ratio of the Imports(as % of merchandise exports) in 1963 in Mexico to that in Portugal?
Make the answer very short. 0.97. What is the ratio of the Imports(as % of merchandise exports) in 1964 in Mexico to that in Portugal?
Ensure brevity in your answer.  1.05. What is the ratio of the Imports(as % of merchandise exports) in 1962 in Mexico to that in Singapore?
Your response must be concise. 3.17. What is the ratio of the Imports(as % of merchandise exports) in 1963 in Mexico to that in Singapore?
Keep it short and to the point. 3.01. What is the ratio of the Imports(as % of merchandise exports) of 1964 in Mexico to that in Singapore?
Offer a terse response. 3.28. What is the ratio of the Imports(as % of merchandise exports) of 1965 in Mexico to that in Singapore?
Provide a short and direct response. 3.01. What is the ratio of the Imports(as % of merchandise exports) in 1962 in Netherlands to that in Paraguay?
Your answer should be very brief. 6.08. What is the ratio of the Imports(as % of merchandise exports) in 1963 in Netherlands to that in Paraguay?
Ensure brevity in your answer.  2.38. What is the ratio of the Imports(as % of merchandise exports) of 1964 in Netherlands to that in Paraguay?
Give a very brief answer. 3.59. What is the ratio of the Imports(as % of merchandise exports) of 1965 in Netherlands to that in Paraguay?
Keep it short and to the point. 3.55. What is the ratio of the Imports(as % of merchandise exports) of 1962 in Netherlands to that in Philippines?
Provide a short and direct response. 3.61. What is the ratio of the Imports(as % of merchandise exports) of 1963 in Netherlands to that in Philippines?
Provide a short and direct response. 1.64. What is the ratio of the Imports(as % of merchandise exports) in 1964 in Netherlands to that in Philippines?
Offer a very short reply. 2.13. What is the ratio of the Imports(as % of merchandise exports) in 1965 in Netherlands to that in Philippines?
Offer a terse response. 2.21. What is the ratio of the Imports(as % of merchandise exports) in 1962 in Netherlands to that in Portugal?
Ensure brevity in your answer.  1.98. What is the ratio of the Imports(as % of merchandise exports) in 1963 in Netherlands to that in Portugal?
Your answer should be compact. 1.13. What is the ratio of the Imports(as % of merchandise exports) in 1964 in Netherlands to that in Portugal?
Ensure brevity in your answer.  1.49. What is the ratio of the Imports(as % of merchandise exports) in 1965 in Netherlands to that in Portugal?
Give a very brief answer. 1.45. What is the ratio of the Imports(as % of merchandise exports) in 1962 in Netherlands to that in Singapore?
Keep it short and to the point. 8.19. What is the ratio of the Imports(as % of merchandise exports) in 1963 in Netherlands to that in Singapore?
Your answer should be compact. 3.52. What is the ratio of the Imports(as % of merchandise exports) of 1964 in Netherlands to that in Singapore?
Provide a short and direct response. 4.63. What is the ratio of the Imports(as % of merchandise exports) in 1965 in Netherlands to that in Singapore?
Provide a succinct answer. 4.36. What is the ratio of the Imports(as % of merchandise exports) in 1962 in Paraguay to that in Philippines?
Keep it short and to the point. 0.59. What is the ratio of the Imports(as % of merchandise exports) in 1963 in Paraguay to that in Philippines?
Keep it short and to the point. 0.69. What is the ratio of the Imports(as % of merchandise exports) in 1964 in Paraguay to that in Philippines?
Provide a short and direct response. 0.59. What is the ratio of the Imports(as % of merchandise exports) of 1965 in Paraguay to that in Philippines?
Ensure brevity in your answer.  0.62. What is the ratio of the Imports(as % of merchandise exports) in 1962 in Paraguay to that in Portugal?
Ensure brevity in your answer.  0.33. What is the ratio of the Imports(as % of merchandise exports) of 1963 in Paraguay to that in Portugal?
Your response must be concise. 0.48. What is the ratio of the Imports(as % of merchandise exports) of 1964 in Paraguay to that in Portugal?
Your answer should be very brief. 0.41. What is the ratio of the Imports(as % of merchandise exports) in 1965 in Paraguay to that in Portugal?
Your answer should be very brief. 0.41. What is the ratio of the Imports(as % of merchandise exports) of 1962 in Paraguay to that in Singapore?
Provide a succinct answer. 1.35. What is the ratio of the Imports(as % of merchandise exports) of 1963 in Paraguay to that in Singapore?
Provide a short and direct response. 1.48. What is the ratio of the Imports(as % of merchandise exports) of 1964 in Paraguay to that in Singapore?
Your answer should be very brief. 1.29. What is the ratio of the Imports(as % of merchandise exports) of 1965 in Paraguay to that in Singapore?
Your answer should be compact. 1.23. What is the ratio of the Imports(as % of merchandise exports) in 1962 in Philippines to that in Portugal?
Make the answer very short. 0.55. What is the ratio of the Imports(as % of merchandise exports) of 1963 in Philippines to that in Portugal?
Provide a succinct answer. 0.69. What is the ratio of the Imports(as % of merchandise exports) in 1964 in Philippines to that in Portugal?
Give a very brief answer. 0.7. What is the ratio of the Imports(as % of merchandise exports) of 1965 in Philippines to that in Portugal?
Your response must be concise. 0.66. What is the ratio of the Imports(as % of merchandise exports) in 1962 in Philippines to that in Singapore?
Provide a short and direct response. 2.27. What is the ratio of the Imports(as % of merchandise exports) of 1963 in Philippines to that in Singapore?
Offer a very short reply. 2.15. What is the ratio of the Imports(as % of merchandise exports) of 1964 in Philippines to that in Singapore?
Offer a very short reply. 2.18. What is the ratio of the Imports(as % of merchandise exports) of 1965 in Philippines to that in Singapore?
Provide a short and direct response. 1.98. What is the ratio of the Imports(as % of merchandise exports) in 1962 in Portugal to that in Singapore?
Keep it short and to the point. 4.15. What is the ratio of the Imports(as % of merchandise exports) of 1963 in Portugal to that in Singapore?
Ensure brevity in your answer.  3.11. What is the ratio of the Imports(as % of merchandise exports) of 1964 in Portugal to that in Singapore?
Offer a terse response. 3.12. What is the ratio of the Imports(as % of merchandise exports) of 1965 in Portugal to that in Singapore?
Provide a short and direct response. 3. What is the difference between the highest and the second highest Imports(as % of merchandise exports) of 1962?
Offer a terse response. 4.04. What is the difference between the highest and the second highest Imports(as % of merchandise exports) of 1963?
Your response must be concise. 0.49. What is the difference between the highest and the second highest Imports(as % of merchandise exports) of 1964?
Your answer should be very brief. 1.58. What is the difference between the highest and the second highest Imports(as % of merchandise exports) of 1965?
Make the answer very short. 1.82. What is the difference between the highest and the lowest Imports(as % of merchandise exports) in 1962?
Your response must be concise. 7.17. What is the difference between the highest and the lowest Imports(as % of merchandise exports) in 1963?
Offer a terse response. 3.02. What is the difference between the highest and the lowest Imports(as % of merchandise exports) in 1964?
Your answer should be compact. 4.26. What is the difference between the highest and the lowest Imports(as % of merchandise exports) in 1965?
Provide a short and direct response. 4.55. 